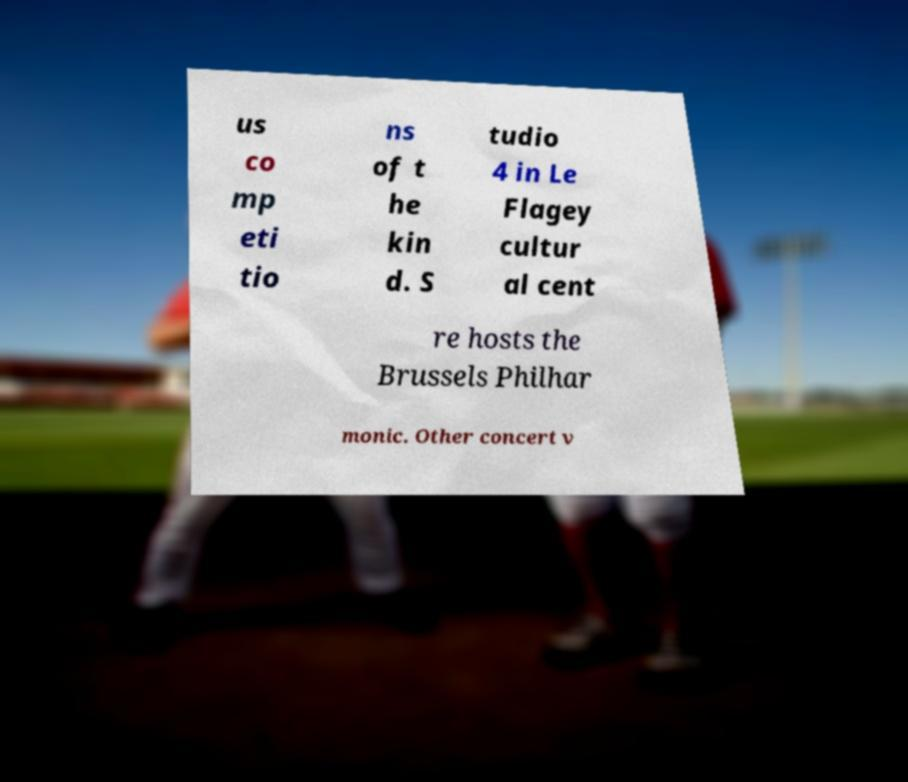Please read and relay the text visible in this image. What does it say? us co mp eti tio ns of t he kin d. S tudio 4 in Le Flagey cultur al cent re hosts the Brussels Philhar monic. Other concert v 